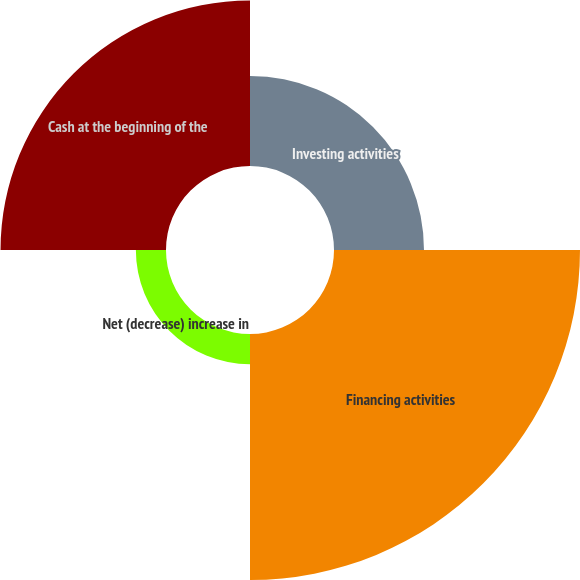Convert chart to OTSL. <chart><loc_0><loc_0><loc_500><loc_500><pie_chart><fcel>Investing activities<fcel>Financing activities<fcel>Net (decrease) increase in<fcel>Cash at the beginning of the<nl><fcel>16.93%<fcel>46.28%<fcel>5.67%<fcel>31.13%<nl></chart> 